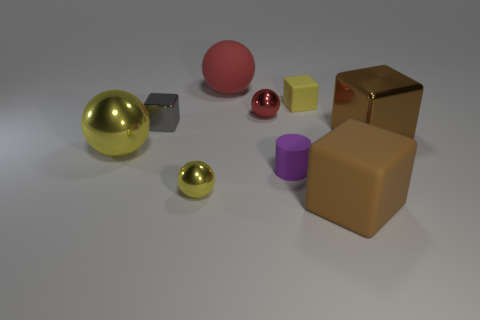Subtract 1 spheres. How many spheres are left? 3 Add 1 gray rubber cylinders. How many objects exist? 10 Subtract all cylinders. How many objects are left? 8 Add 1 tiny rubber blocks. How many tiny rubber blocks exist? 2 Subtract 0 red cylinders. How many objects are left? 9 Subtract all red metallic balls. Subtract all metal spheres. How many objects are left? 5 Add 5 big red spheres. How many big red spheres are left? 6 